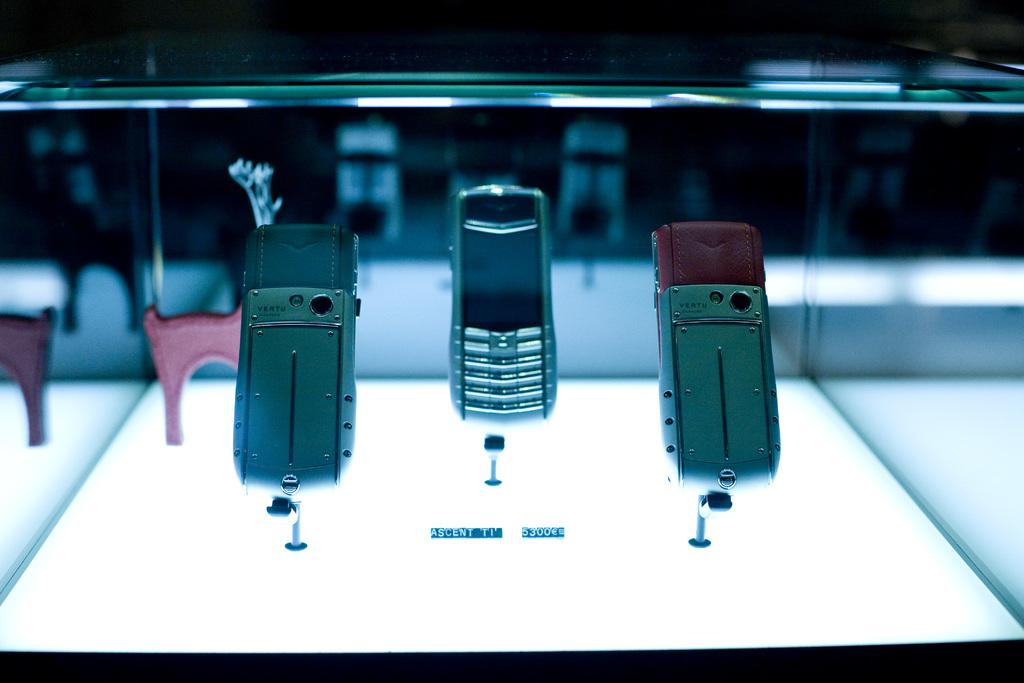<image>
Offer a succinct explanation of the picture presented. Three phones on a display shelf made by the company VERTU. 